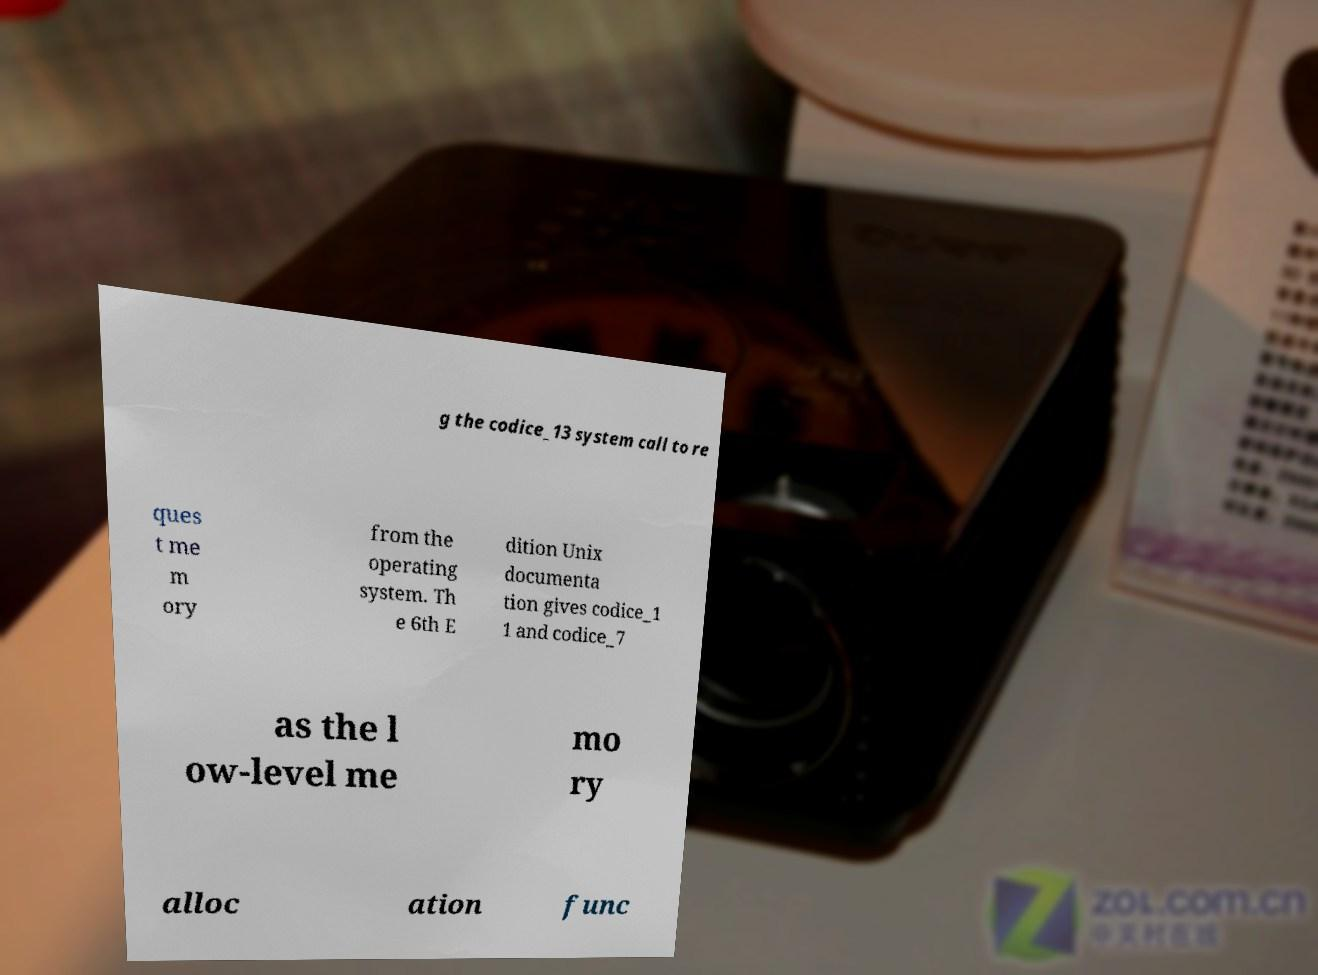Could you assist in decoding the text presented in this image and type it out clearly? g the codice_13 system call to re ques t me m ory from the operating system. Th e 6th E dition Unix documenta tion gives codice_1 1 and codice_7 as the l ow-level me mo ry alloc ation func 